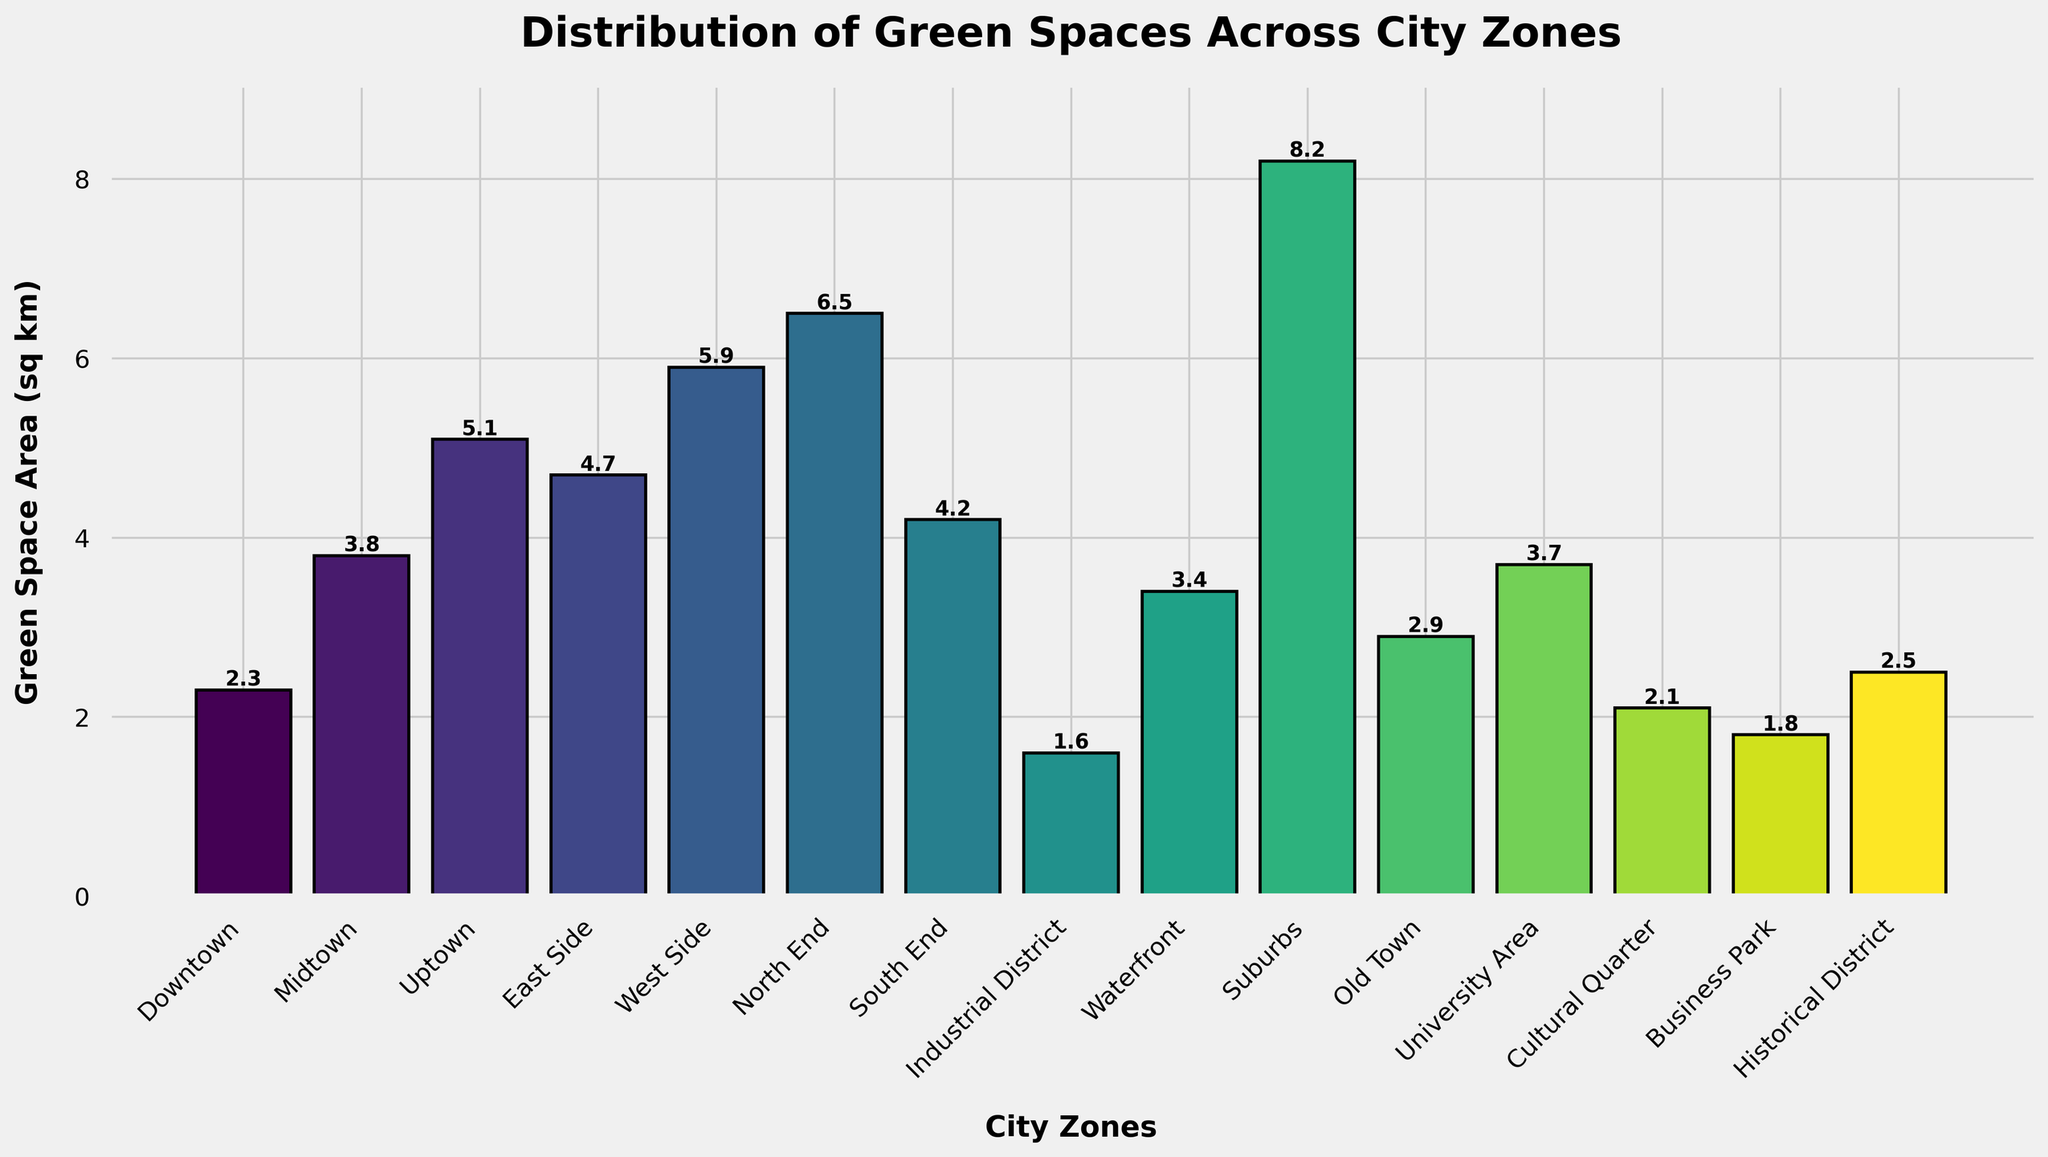Which city zone has the largest green space area? The bar for the Suburbs zone extends the highest, indicating that it has the largest green space area.
Answer: Suburbs How much larger is the green space area in the North End compared to the Industrial District? Subtract the green space area of the Industrial District (1.6 sq km) from the green space area of the North End (6.5 sq km): 6.5 - 1.6 = 4.9 sq km.
Answer: 4.9 sq km Which city zones have green space areas larger than 5 sq km? The bars for the North End, Suburbs, West Side, and Uptown extend above the 5 sq km mark, so these zones have green space areas larger than 5 sq km.
Answer: North End, Suburbs, West Side, Uptown What's the total green space area for the East Side, West Side, and Waterfront zones combined? Sum the green space areas: East Side (4.7 sq km) + West Side (5.9 sq km) + Waterfront (3.4 sq km) = 4.7 + 5.9 + 3.4 = 14 sq km.
Answer: 14 sq km Is the green space area in the Downtown zone less than, equal to, or more than the area in the Old Town zone? The bar for the Downtown zone reaches 2.3 sq km, while the bar for the Old Town zone reaches 2.9 sq km. Therefore, the Downtown zone has less green space area than the Old Town zone.
Answer: Less than What is the average green space area across all zones? Sum all the green space areas and divide by the number of zones (15): (2.3 + 3.8 + 5.1 + 4.7 + 5.9 + 6.5 + 4.2 + 1.6 + 3.4 + 8.2 + 2.9 + 3.7 + 2.1 + 1.8 + 2.5) / 15 = 58.7 / 15 ≈ 3.91 sq km.
Answer: 3.91 sq km Does any city zone have a green space area exactly 5 sq km? The bar for the Uptown zone reaches 5.1 sq km, which is close but not exactly 5 sq km. No other bar reaches exactly 5 sq km.
Answer: No Which city zone has the smallest green space area? The bar for the Industrial District extends the lowest, indicating that it has the smallest green space area.
Answer: Industrial District What are the green space areas for the Cultural Quarter and University Area combined? Sum the green space areas for these zones: Cultural Quarter (2.1 sq km) + University Area (3.7 sq km) = 2.1 + 3.7 = 5.8 sq km.
Answer: 5.8 sq km 